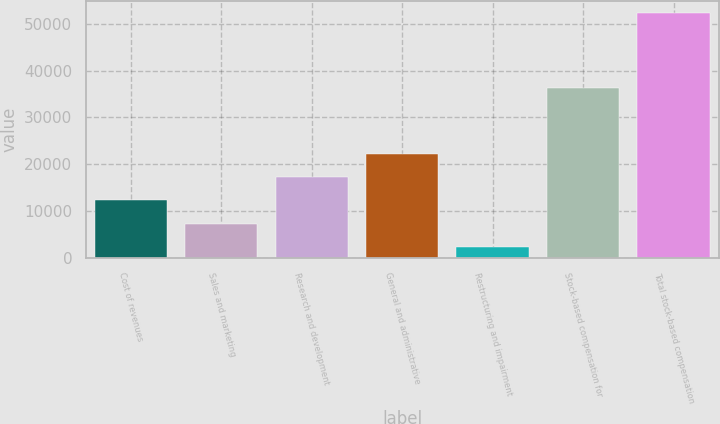Convert chart. <chart><loc_0><loc_0><loc_500><loc_500><bar_chart><fcel>Cost of revenues<fcel>Sales and marketing<fcel>Research and development<fcel>General and administrative<fcel>Restructuring and impairment<fcel>Stock-based compensation for<fcel>Total stock-based compensation<nl><fcel>12292.4<fcel>7306.7<fcel>17278.1<fcel>22263.8<fcel>2321<fcel>36338<fcel>52178<nl></chart> 